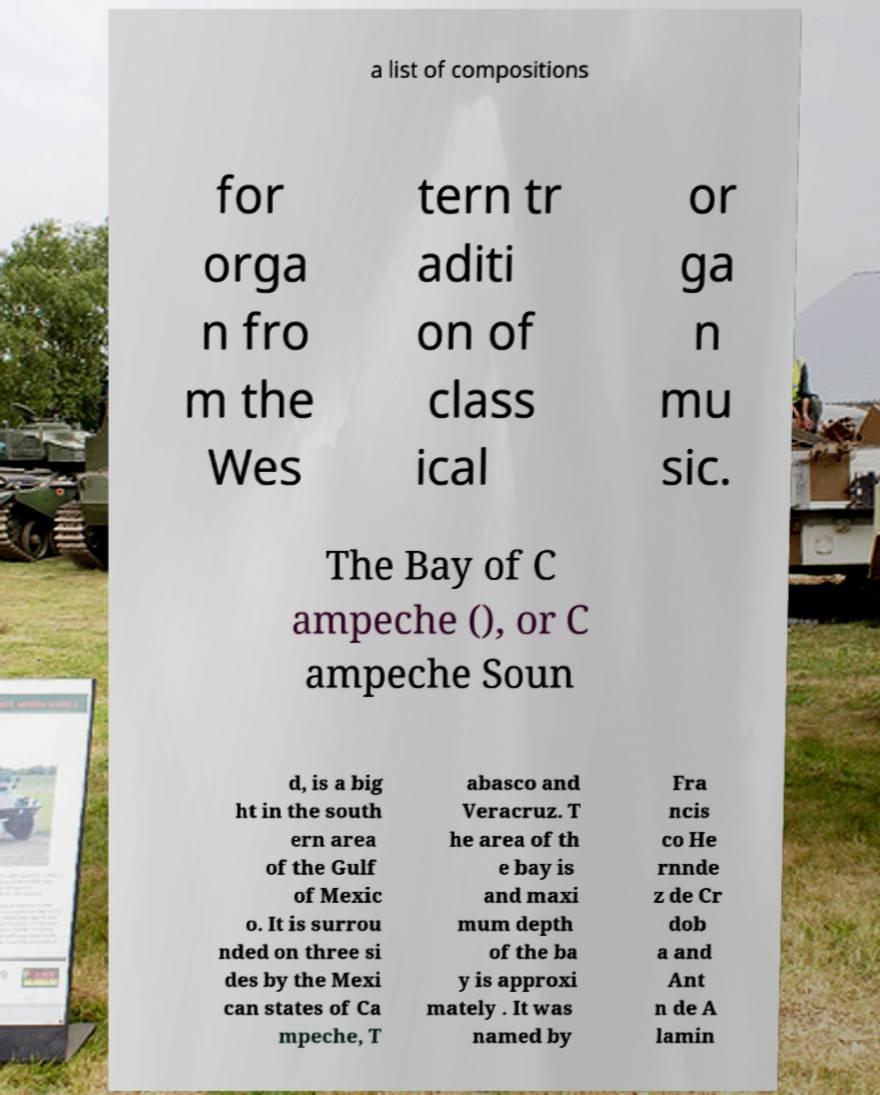Please read and relay the text visible in this image. What does it say? a list of compositions for orga n fro m the Wes tern tr aditi on of class ical or ga n mu sic. The Bay of C ampeche (), or C ampeche Soun d, is a big ht in the south ern area of the Gulf of Mexic o. It is surrou nded on three si des by the Mexi can states of Ca mpeche, T abasco and Veracruz. T he area of th e bay is and maxi mum depth of the ba y is approxi mately . It was named by Fra ncis co He rnnde z de Cr dob a and Ant n de A lamin 